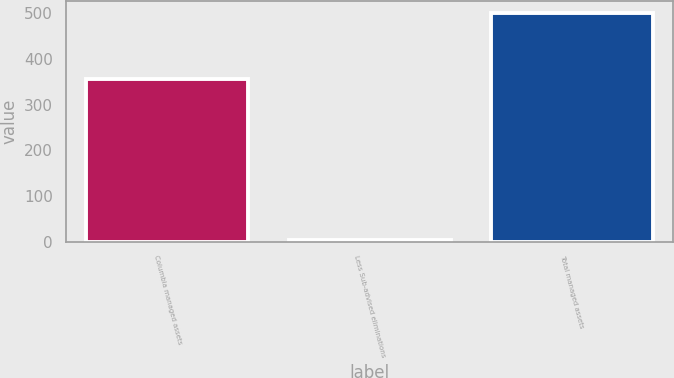Convert chart. <chart><loc_0><loc_0><loc_500><loc_500><bar_chart><fcel>Columbia managed assets<fcel>Less Sub-advised eliminations<fcel>Total managed assets<nl><fcel>356.7<fcel>3.3<fcel>500.8<nl></chart> 